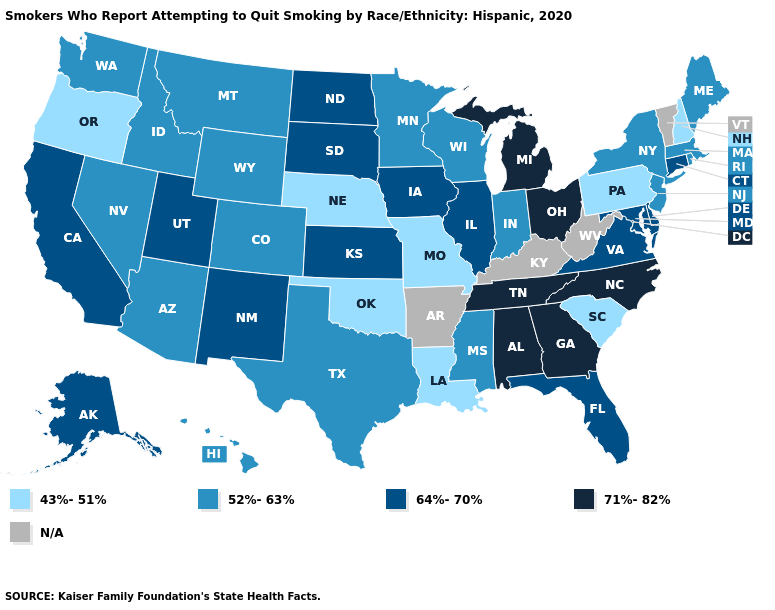What is the value of Oregon?
Write a very short answer. 43%-51%. How many symbols are there in the legend?
Give a very brief answer. 5. Name the states that have a value in the range 52%-63%?
Answer briefly. Arizona, Colorado, Hawaii, Idaho, Indiana, Maine, Massachusetts, Minnesota, Mississippi, Montana, Nevada, New Jersey, New York, Rhode Island, Texas, Washington, Wisconsin, Wyoming. Does the map have missing data?
Be succinct. Yes. Name the states that have a value in the range 43%-51%?
Keep it brief. Louisiana, Missouri, Nebraska, New Hampshire, Oklahoma, Oregon, Pennsylvania, South Carolina. Among the states that border South Dakota , which have the lowest value?
Concise answer only. Nebraska. Which states have the highest value in the USA?
Quick response, please. Alabama, Georgia, Michigan, North Carolina, Ohio, Tennessee. What is the value of Michigan?
Quick response, please. 71%-82%. Name the states that have a value in the range 43%-51%?
Concise answer only. Louisiana, Missouri, Nebraska, New Hampshire, Oklahoma, Oregon, Pennsylvania, South Carolina. What is the value of North Dakota?
Answer briefly. 64%-70%. Does the first symbol in the legend represent the smallest category?
Short answer required. Yes. Name the states that have a value in the range 43%-51%?
Keep it brief. Louisiana, Missouri, Nebraska, New Hampshire, Oklahoma, Oregon, Pennsylvania, South Carolina. What is the value of Oregon?
Answer briefly. 43%-51%. What is the lowest value in the South?
Quick response, please. 43%-51%. 